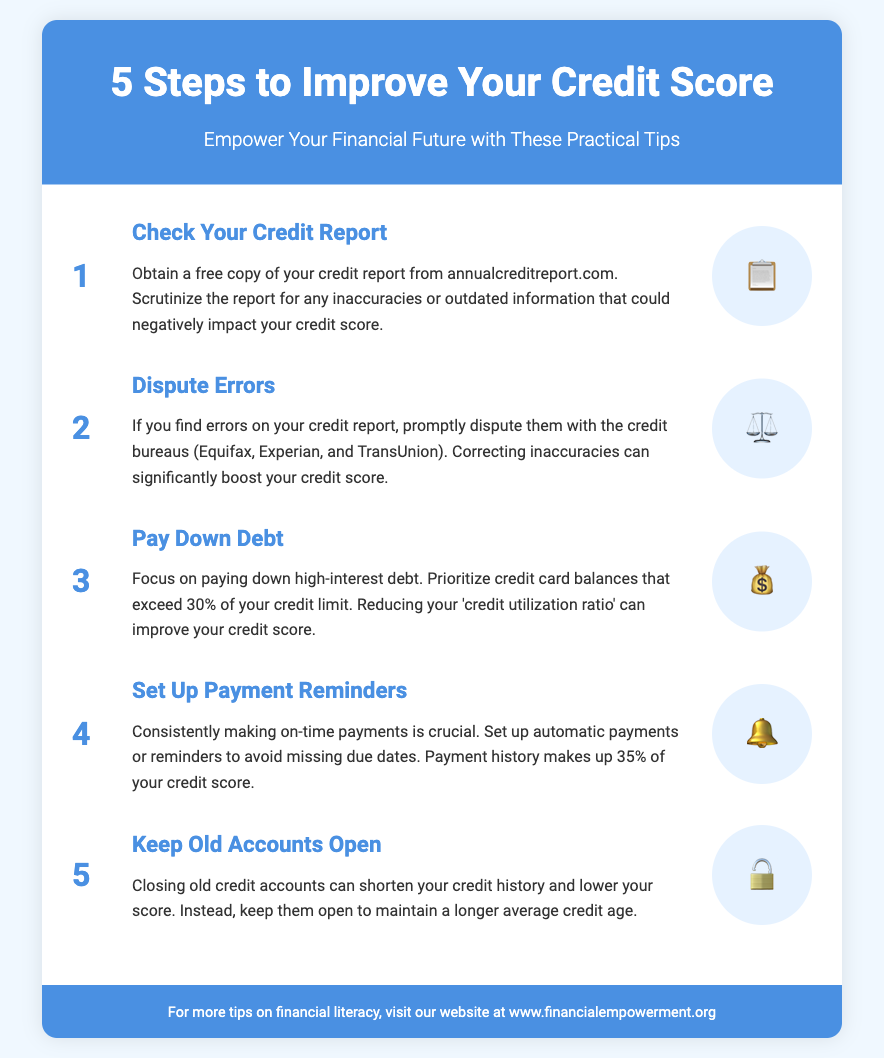What is the first step to improve your credit score? The first step is to check your credit report.
Answer: Check Your Credit Report How many credit bureaus are mentioned? The document mentions three credit bureaus that need to be contacted if there are errors.
Answer: Three What percentage of your credit score is affected by payment history? The document states that payment history makes up a significant percentage of the credit score.
Answer: 35% What should you do if you find errors in your credit report? The document advises to dispute the errors with the credit bureaus.
Answer: Dispute them What does "credit utilization ratio" refer to? The document refers to a specific ratio related to credit card balances and credit limits.
Answer: Credit limits What is the emoji used to represent setting up payment reminders? The visual representation for setting up payment reminders is an emoji depicting a bell.
Answer: 🔔 What is suggested to maintain a longer average credit age? The document suggests to keep old accounts open.
Answer: Keep old accounts open How should you prioritize paying down debt? The document states to focus on paying down high-interest debt.
Answer: High-interest debt What is the website for more financial literacy tips? The footer of the document provides the website for more financial tips.
Answer: www.financialempowerment.org 